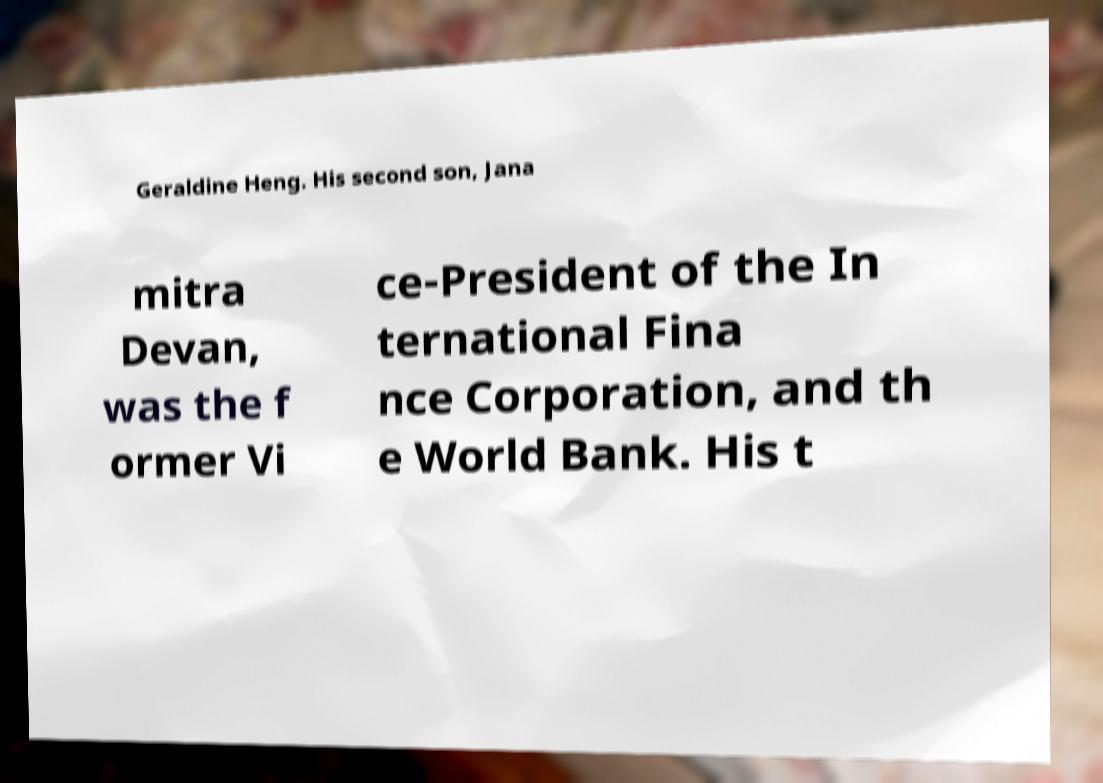There's text embedded in this image that I need extracted. Can you transcribe it verbatim? Geraldine Heng. His second son, Jana mitra Devan, was the f ormer Vi ce-President of the In ternational Fina nce Corporation, and th e World Bank. His t 